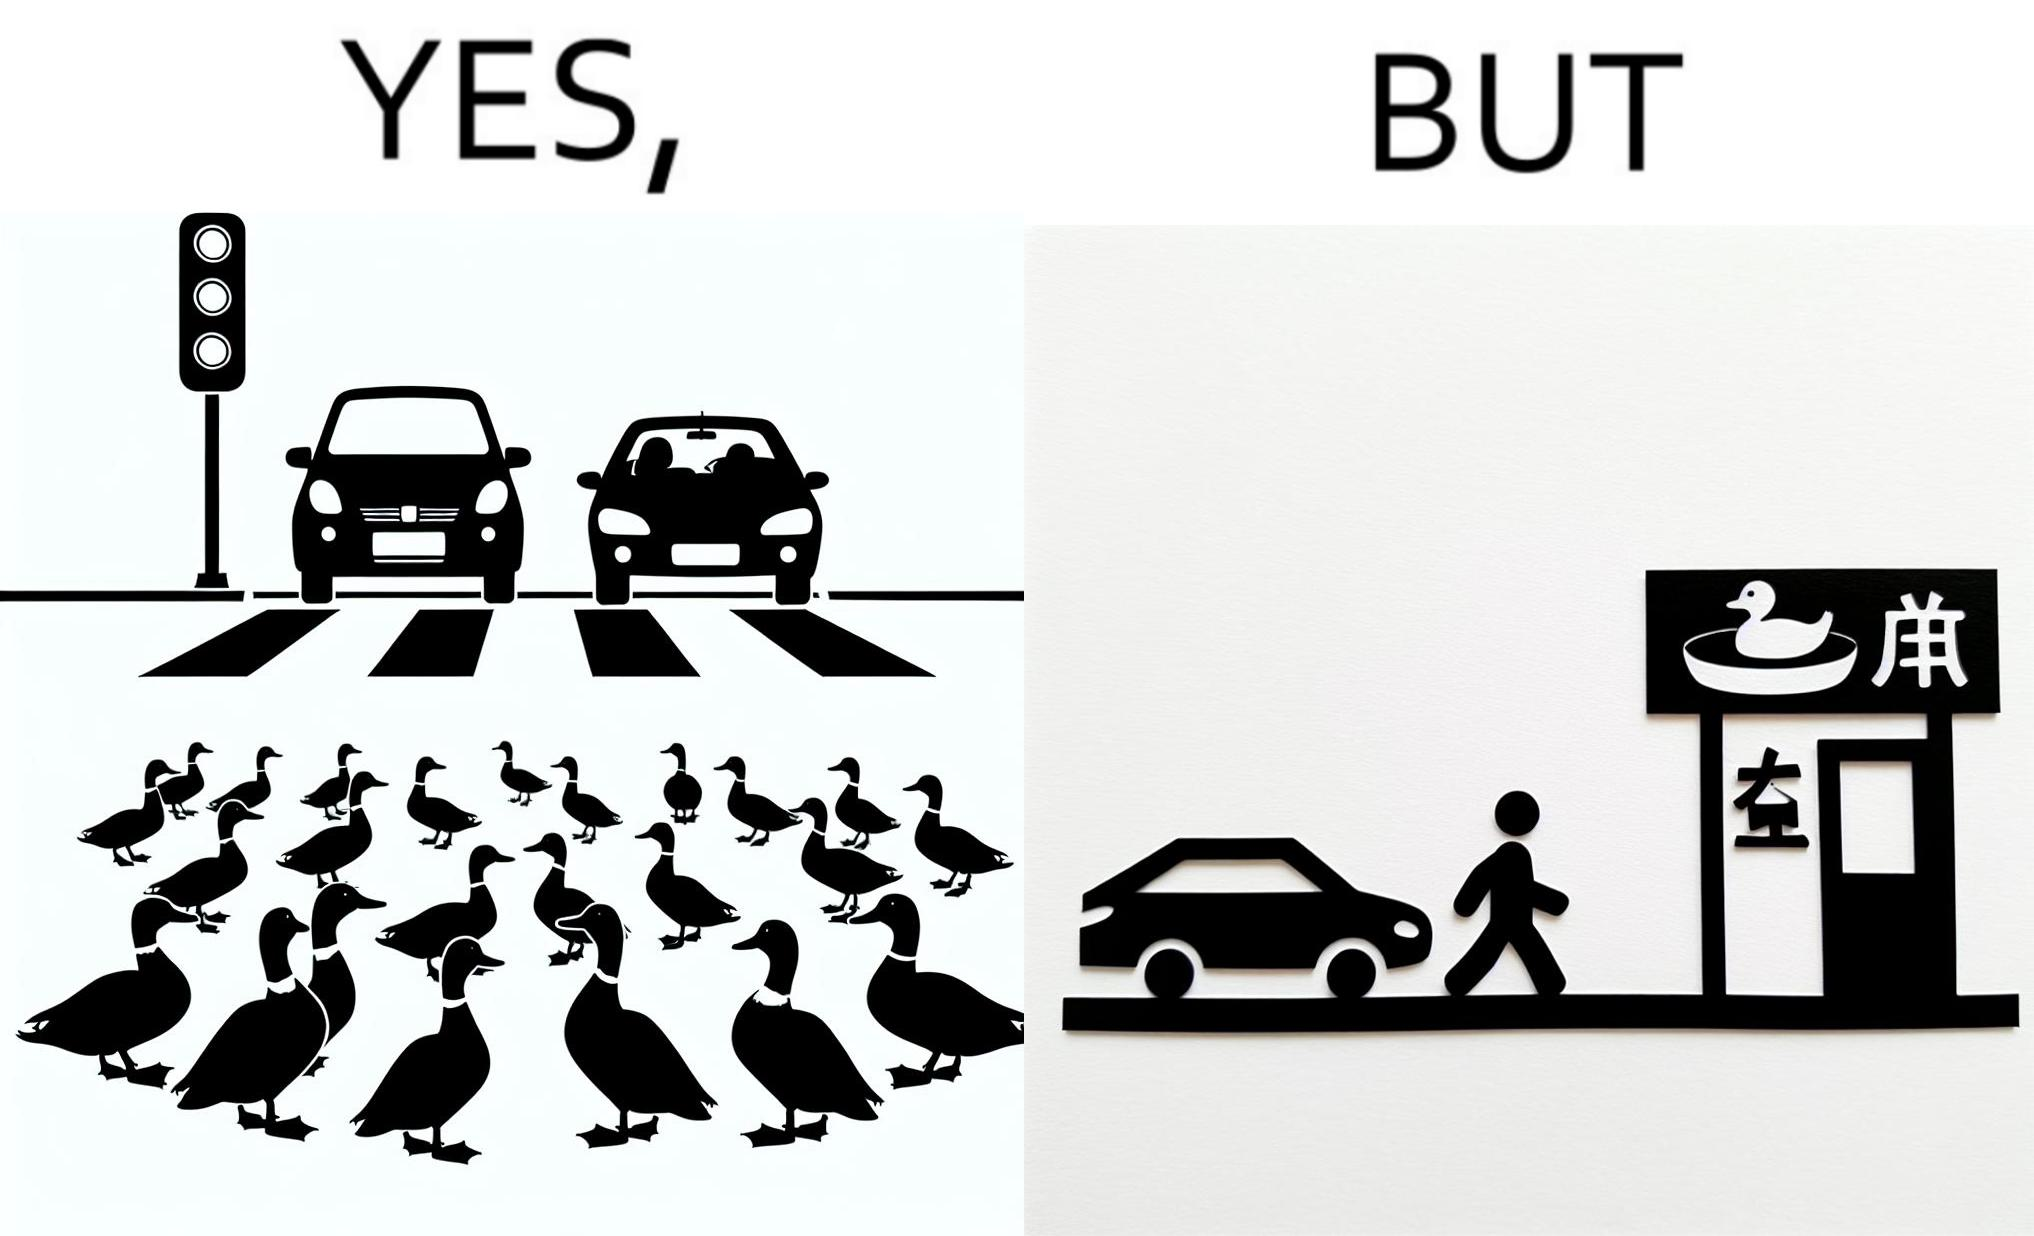What is the satirical meaning behind this image? The images are ironic since they show how a man supposedly cares for ducks since he stops his vehicle to give way to queue of ducks allowing them to safely cross a road but on the other hand he goes to a peking duck shop to buy and eat similar ducks after having them killed 